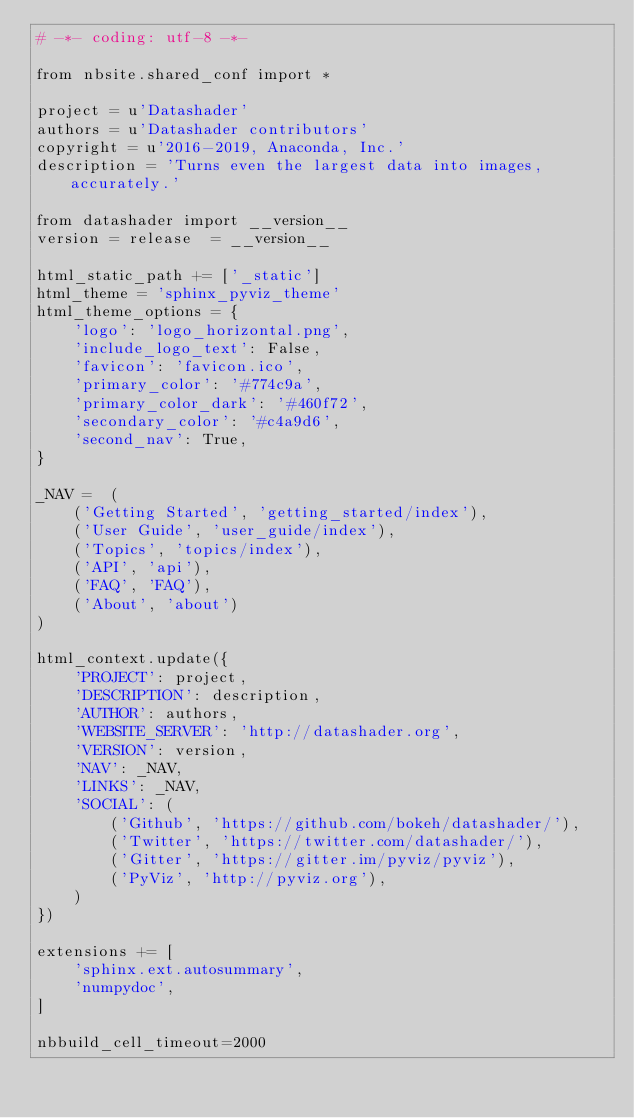Convert code to text. <code><loc_0><loc_0><loc_500><loc_500><_Python_># -*- coding: utf-8 -*-

from nbsite.shared_conf import *

project = u'Datashader'
authors = u'Datashader contributors'
copyright = u'2016-2019, Anaconda, Inc.'
description = 'Turns even the largest data into images, accurately.'

from datashader import __version__
version = release  = __version__

html_static_path += ['_static']
html_theme = 'sphinx_pyviz_theme'
html_theme_options = {
    'logo': 'logo_horizontal.png',
    'include_logo_text': False,
    'favicon': 'favicon.ico',
    'primary_color': '#774c9a',
    'primary_color_dark': '#460f72',
    'secondary_color': '#c4a9d6',
    'second_nav': True,
}

_NAV =  (
    ('Getting Started', 'getting_started/index'),
    ('User Guide', 'user_guide/index'),
    ('Topics', 'topics/index'),
    ('API', 'api'),
    ('FAQ', 'FAQ'),
    ('About', 'about')
)

html_context.update({
    'PROJECT': project,
    'DESCRIPTION': description,
    'AUTHOR': authors,
    'WEBSITE_SERVER': 'http://datashader.org',
    'VERSION': version,
    'NAV': _NAV,
    'LINKS': _NAV,
    'SOCIAL': (
        ('Github', 'https://github.com/bokeh/datashader/'),
        ('Twitter', 'https://twitter.com/datashader/'),
        ('Gitter', 'https://gitter.im/pyviz/pyviz'),
        ('PyViz', 'http://pyviz.org'),
    )
})

extensions += [
    'sphinx.ext.autosummary',
    'numpydoc',
]

nbbuild_cell_timeout=2000
</code> 